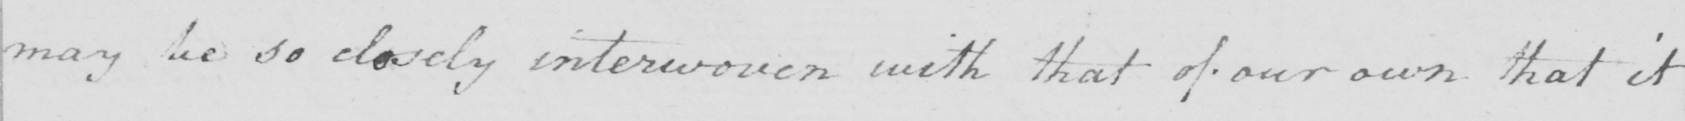What is written in this line of handwriting? may be so closely interwoven with that of our own that it 